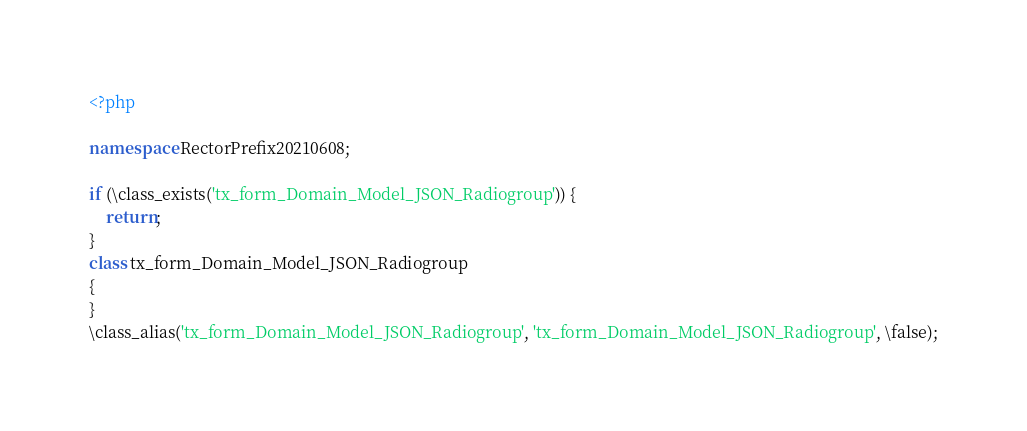Convert code to text. <code><loc_0><loc_0><loc_500><loc_500><_PHP_><?php

namespace RectorPrefix20210608;

if (\class_exists('tx_form_Domain_Model_JSON_Radiogroup')) {
    return;
}
class tx_form_Domain_Model_JSON_Radiogroup
{
}
\class_alias('tx_form_Domain_Model_JSON_Radiogroup', 'tx_form_Domain_Model_JSON_Radiogroup', \false);
</code> 